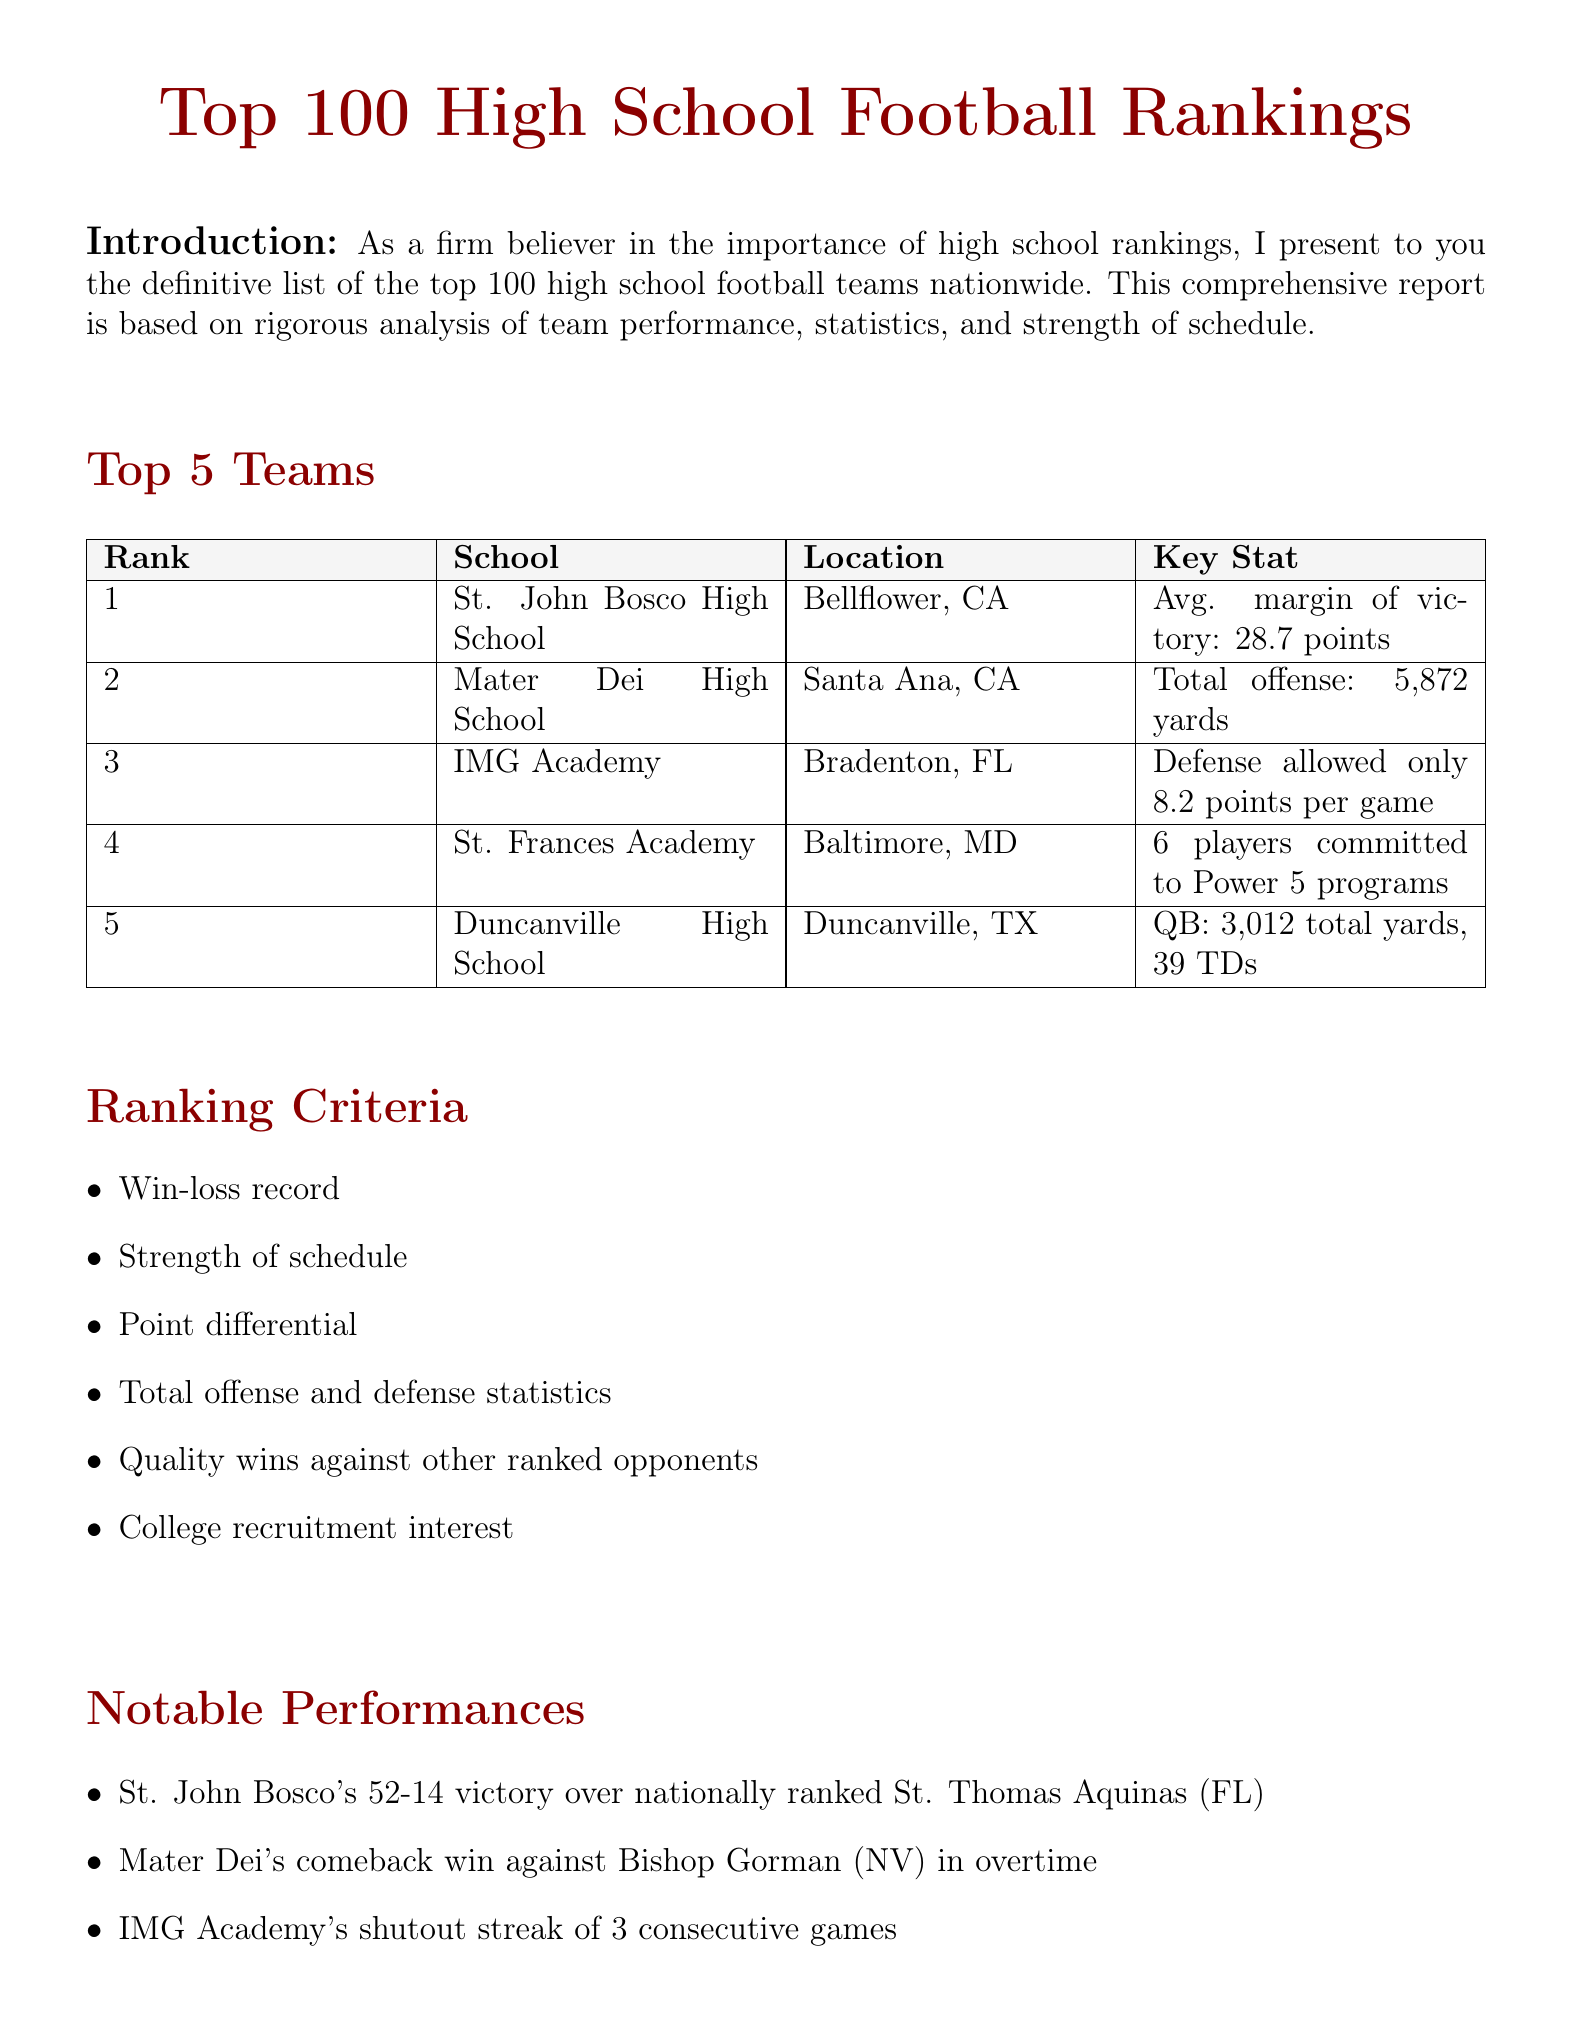what is the rank of St. John Bosco High School? The rank of St. John Bosco High School is mentioned in the rankings section of the document.
Answer: 1 what is the record of Duncanville High School? The document provides the record of Duncanville High School in the top teams section.
Answer: 14-1 how many players from St. Frances Academy are committed to Power 5 programs? The number of players committed is a key statistic listed under St. Frances Academy.
Answer: 6 what criteria is used to evaluate high school football teams? The criteria for ranking high school football teams are outlined in a dedicated section of the document.
Answer: Win-loss record, Strength of schedule, Point differential, Total offense and defense statistics, Quality wins against other ranked opponents, College recruitment interest which team had a notable victory against St. Thomas Aquinas? The notable performances section highlights specific victories, including this one.
Answer: St. John Bosco what is the average margin of victory for St. John Bosco High School? This statistic is specifically mentioned as a key stat for St. John Bosco in the rankings.
Answer: 28.7 points which team's defense allowed only 8.2 points per game? This statistic is listed as a key stat for one of the top teams in the rankings.
Answer: IMG Academy what is the total offense of Mater Dei High School? The total offense is highlighted as a key statistic for Mater Dei in the document.
Answer: 5,872 yards 